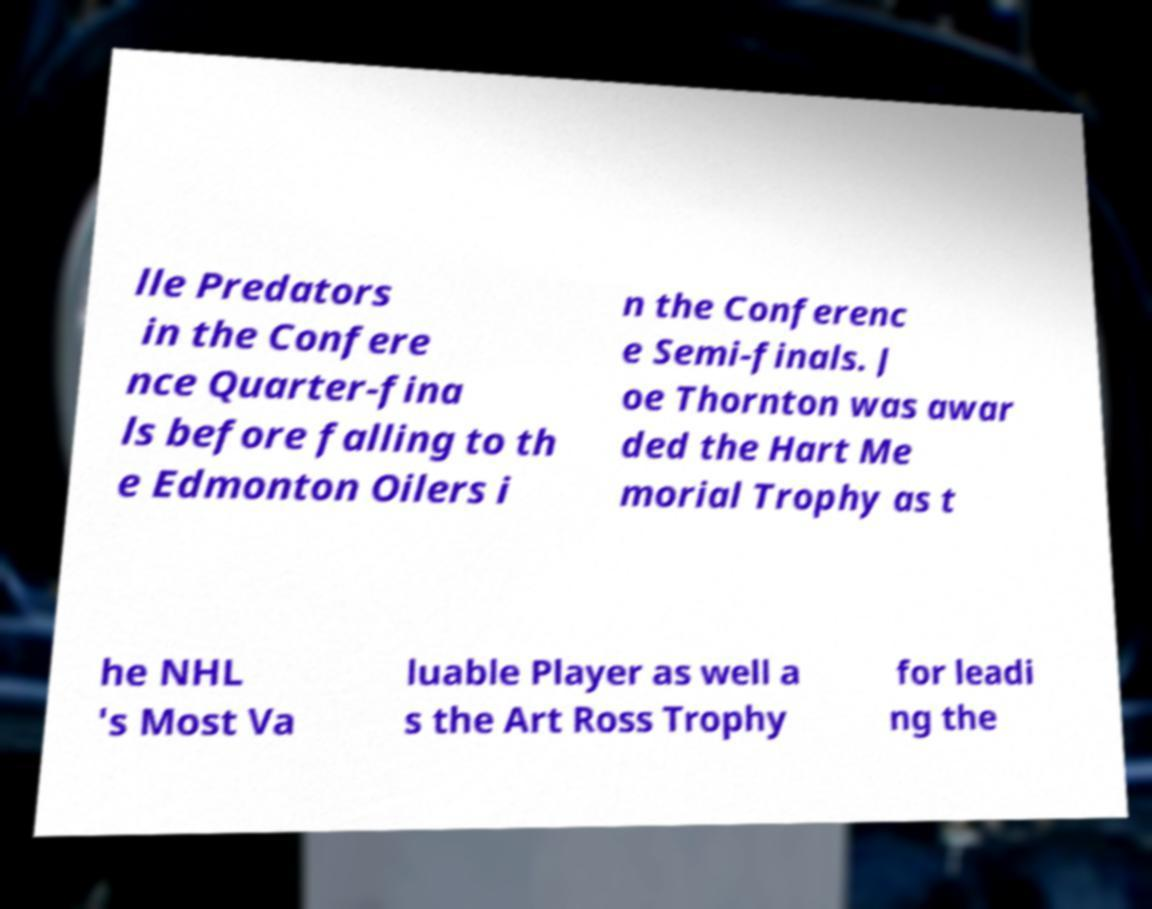What messages or text are displayed in this image? I need them in a readable, typed format. lle Predators in the Confere nce Quarter-fina ls before falling to th e Edmonton Oilers i n the Conferenc e Semi-finals. J oe Thornton was awar ded the Hart Me morial Trophy as t he NHL 's Most Va luable Player as well a s the Art Ross Trophy for leadi ng the 